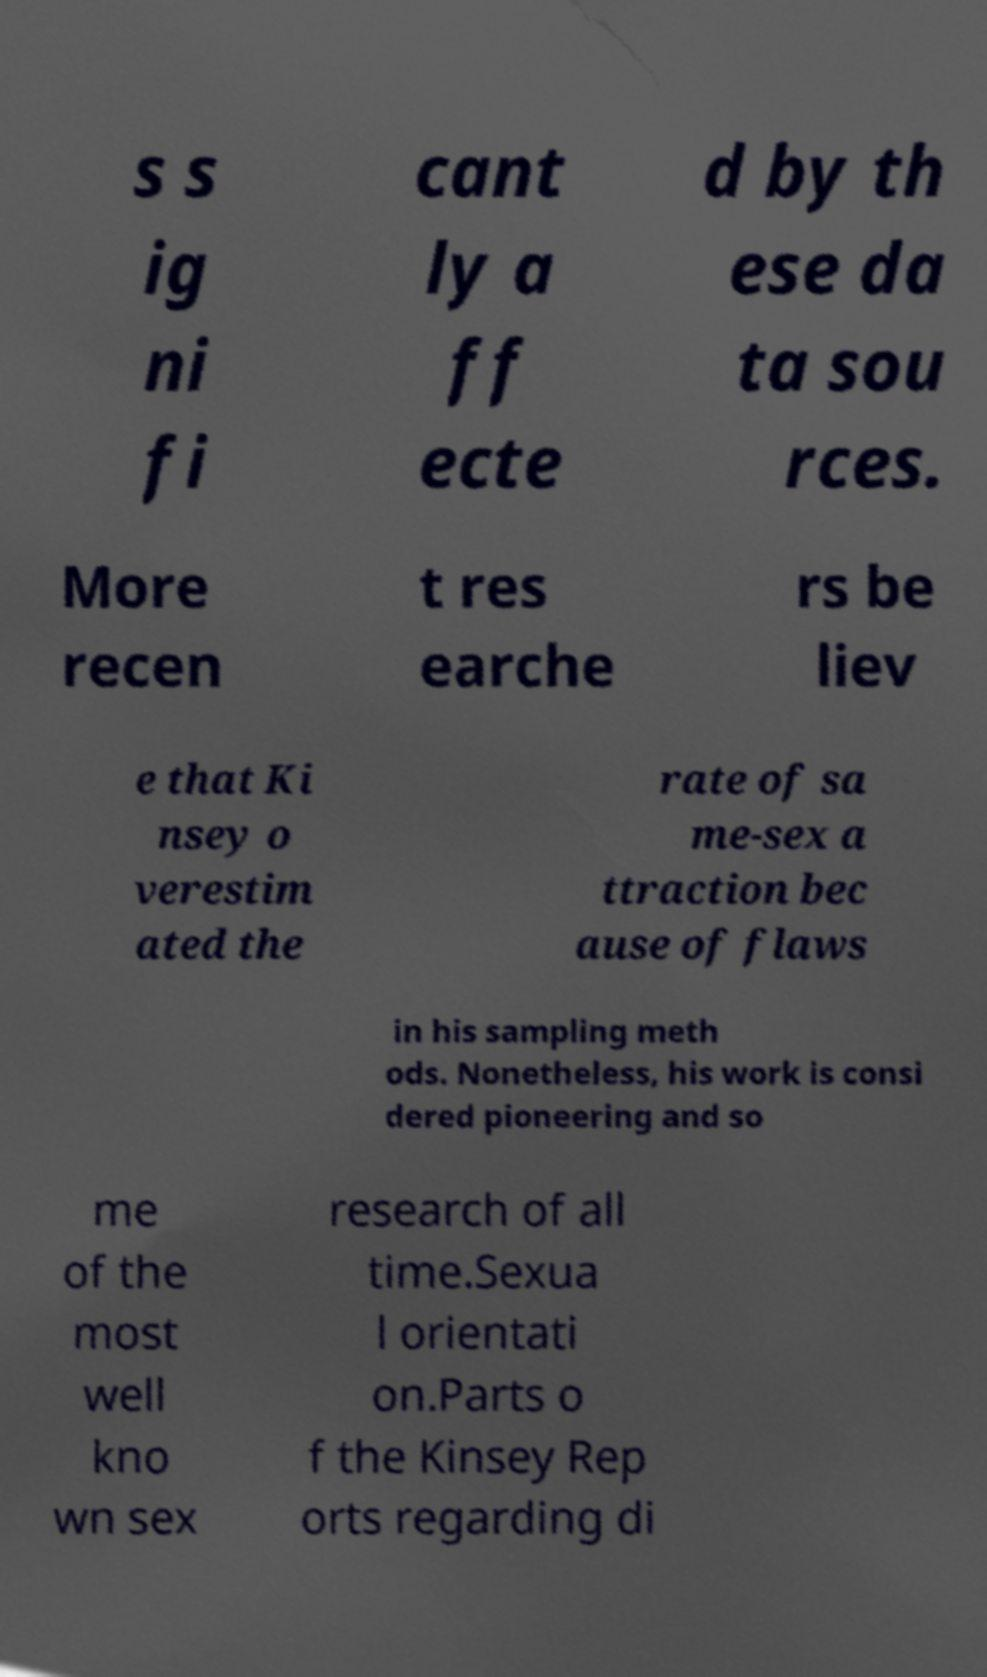Can you read and provide the text displayed in the image?This photo seems to have some interesting text. Can you extract and type it out for me? s s ig ni fi cant ly a ff ecte d by th ese da ta sou rces. More recen t res earche rs be liev e that Ki nsey o verestim ated the rate of sa me-sex a ttraction bec ause of flaws in his sampling meth ods. Nonetheless, his work is consi dered pioneering and so me of the most well kno wn sex research of all time.Sexua l orientati on.Parts o f the Kinsey Rep orts regarding di 